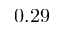Convert formula to latex. <formula><loc_0><loc_0><loc_500><loc_500>0 . 2 9</formula> 